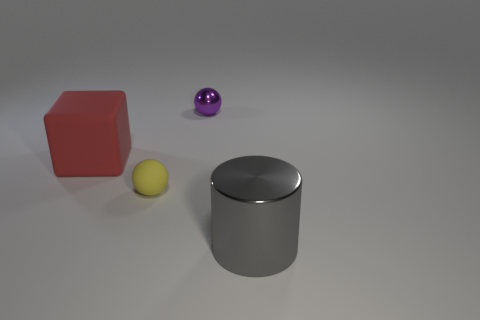There is a metal thing in front of the big thing that is behind the yellow object; what size is it?
Ensure brevity in your answer.  Large. There is a metal object that is to the left of the cylinder; is its shape the same as the tiny object in front of the cube?
Your response must be concise. Yes. There is a shiny object that is behind the large object that is in front of the big red matte block; what is its shape?
Your answer should be compact. Sphere. There is a object that is behind the yellow rubber ball and to the left of the tiny purple shiny sphere; what is its size?
Offer a terse response. Large. There is a purple shiny object; is its shape the same as the rubber object to the right of the big block?
Offer a very short reply. Yes. How many other objects are the same size as the purple metal sphere?
Keep it short and to the point. 1. There is a object on the right side of the small sphere that is on the right side of the tiny ball left of the purple shiny thing; what shape is it?
Provide a succinct answer. Cylinder. There is a gray cylinder; is its size the same as the metal thing behind the cylinder?
Offer a terse response. No. What color is the object that is in front of the cube and on the left side of the metallic cylinder?
Provide a short and direct response. Yellow. How many other things are there of the same shape as the gray metal thing?
Offer a very short reply. 0. 